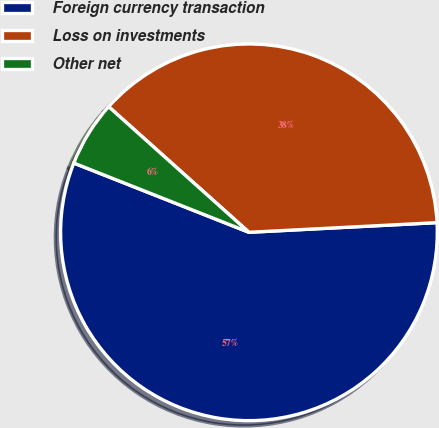Convert chart. <chart><loc_0><loc_0><loc_500><loc_500><pie_chart><fcel>Foreign currency transaction<fcel>Loss on investments<fcel>Other net<nl><fcel>56.81%<fcel>37.56%<fcel>5.63%<nl></chart> 